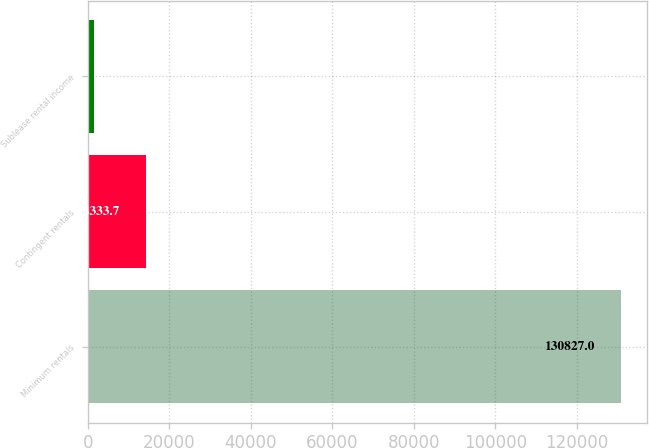<chart> <loc_0><loc_0><loc_500><loc_500><bar_chart><fcel>Minimum rentals<fcel>Contingent rentals<fcel>Sublease rental income<nl><fcel>130827<fcel>14333.7<fcel>1390<nl></chart> 